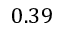<formula> <loc_0><loc_0><loc_500><loc_500>0 . 3 9</formula> 